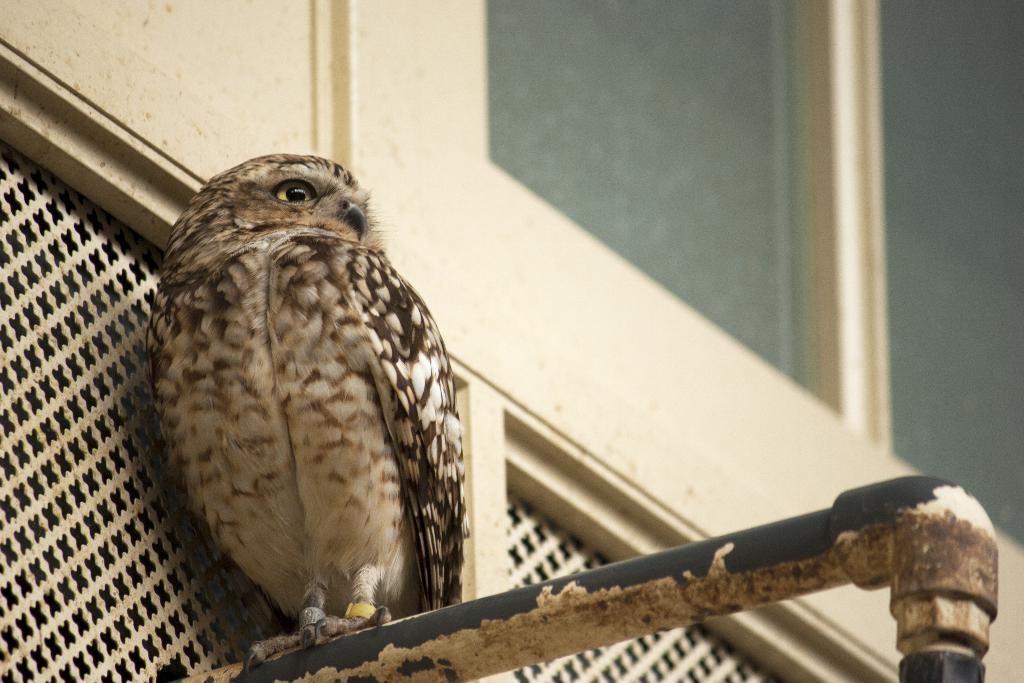Please provide a concise description of this image. In this picture, we see an owl is on the iron pipe. Behind that, we see a wall in white color. In the right top of the picture, we see windows. 